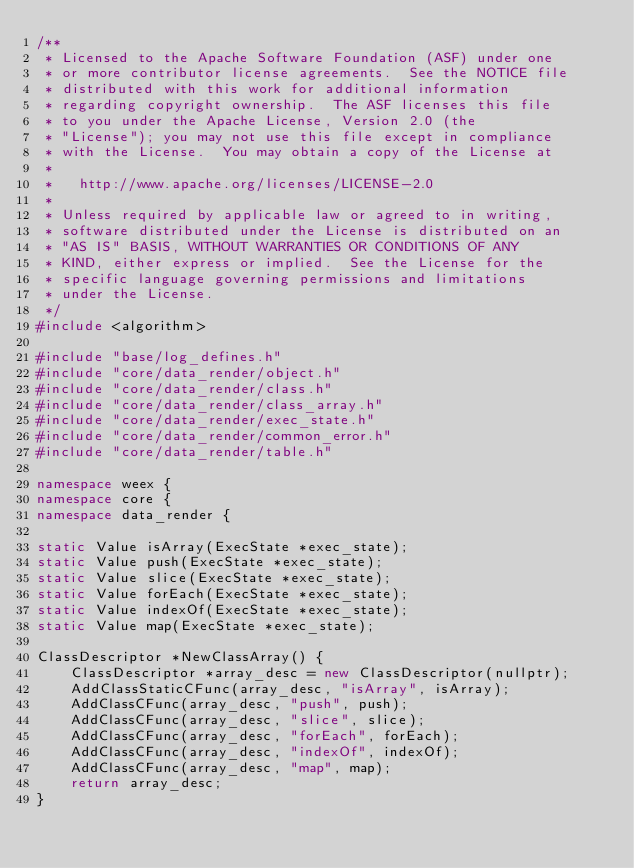<code> <loc_0><loc_0><loc_500><loc_500><_C++_>/**
 * Licensed to the Apache Software Foundation (ASF) under one
 * or more contributor license agreements.  See the NOTICE file
 * distributed with this work for additional information
 * regarding copyright ownership.  The ASF licenses this file
 * to you under the Apache License, Version 2.0 (the
 * "License"); you may not use this file except in compliance
 * with the License.  You may obtain a copy of the License at
 *
 *   http://www.apache.org/licenses/LICENSE-2.0
 *
 * Unless required by applicable law or agreed to in writing,
 * software distributed under the License is distributed on an
 * "AS IS" BASIS, WITHOUT WARRANTIES OR CONDITIONS OF ANY
 * KIND, either express or implied.  See the License for the
 * specific language governing permissions and limitations
 * under the License.
 */
#include <algorithm>

#include "base/log_defines.h"
#include "core/data_render/object.h"
#include "core/data_render/class.h"
#include "core/data_render/class_array.h"
#include "core/data_render/exec_state.h"
#include "core/data_render/common_error.h"
#include "core/data_render/table.h"

namespace weex {
namespace core {
namespace data_render {

static Value isArray(ExecState *exec_state);
static Value push(ExecState *exec_state);
static Value slice(ExecState *exec_state);
static Value forEach(ExecState *exec_state);
static Value indexOf(ExecState *exec_state);
static Value map(ExecState *exec_state);

ClassDescriptor *NewClassArray() {
    ClassDescriptor *array_desc = new ClassDescriptor(nullptr);
    AddClassStaticCFunc(array_desc, "isArray", isArray);
    AddClassCFunc(array_desc, "push", push);
    AddClassCFunc(array_desc, "slice", slice);
    AddClassCFunc(array_desc, "forEach", forEach);
    AddClassCFunc(array_desc, "indexOf", indexOf);
    AddClassCFunc(array_desc, "map", map);
    return array_desc;
}
</code> 